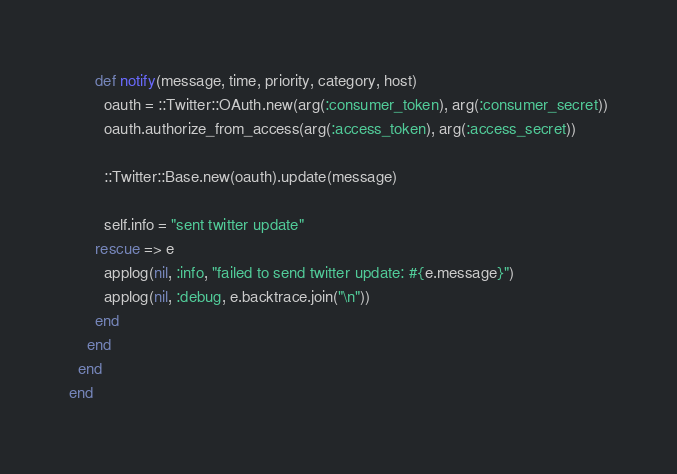Convert code to text. <code><loc_0><loc_0><loc_500><loc_500><_Ruby_>
      def notify(message, time, priority, category, host)
        oauth = ::Twitter::OAuth.new(arg(:consumer_token), arg(:consumer_secret))
        oauth.authorize_from_access(arg(:access_token), arg(:access_secret))

        ::Twitter::Base.new(oauth).update(message)

        self.info = "sent twitter update"
      rescue => e
        applog(nil, :info, "failed to send twitter update: #{e.message}")
        applog(nil, :debug, e.backtrace.join("\n"))
      end
    end
  end
end
</code> 